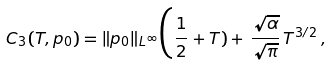Convert formula to latex. <formula><loc_0><loc_0><loc_500><loc_500>C _ { 3 } ( T , p _ { 0 } ) = \| p _ { 0 } \| _ { L ^ { \infty } } \Big ( \frac { 1 } { 2 } + T ) + \, \frac { \sqrt { \alpha } } { \sqrt { \pi } } \, T ^ { 3 / 2 } \, ,</formula> 